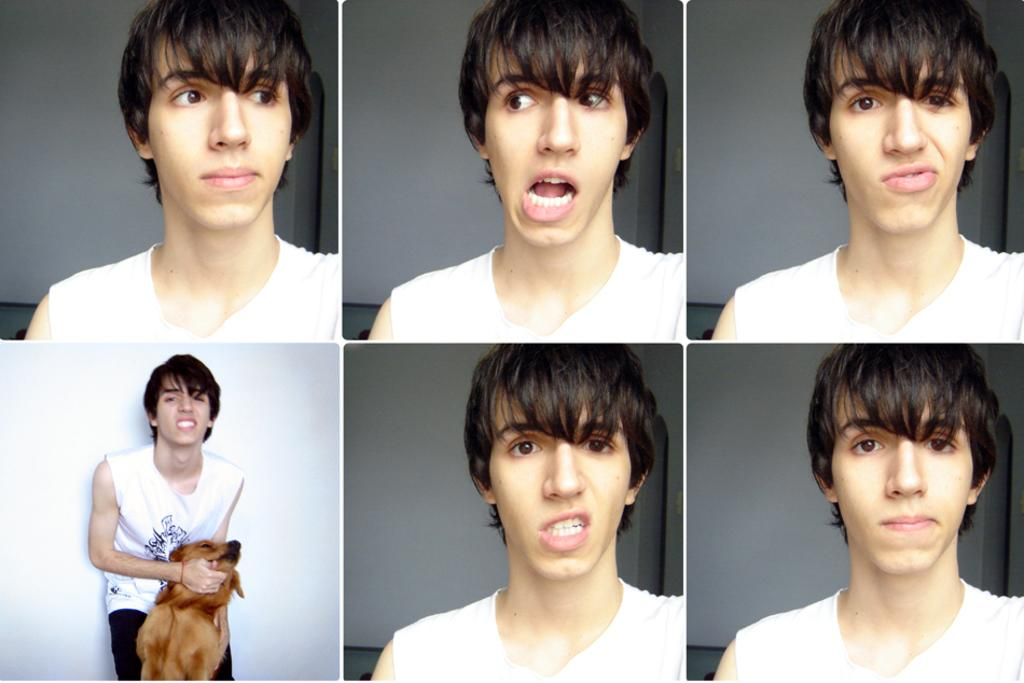Who is the main subject in the image? There is a man in the image. What is the man wearing? The man is wearing a white T-shirt. What is the man doing with his hand? The man is holding a dog with his hand. How is the man expressing himself in the image? The man is displaying various expressions on his face. What type of bulb is the man holding in the image? There is no bulb present in the image; the man is holding a dog. 